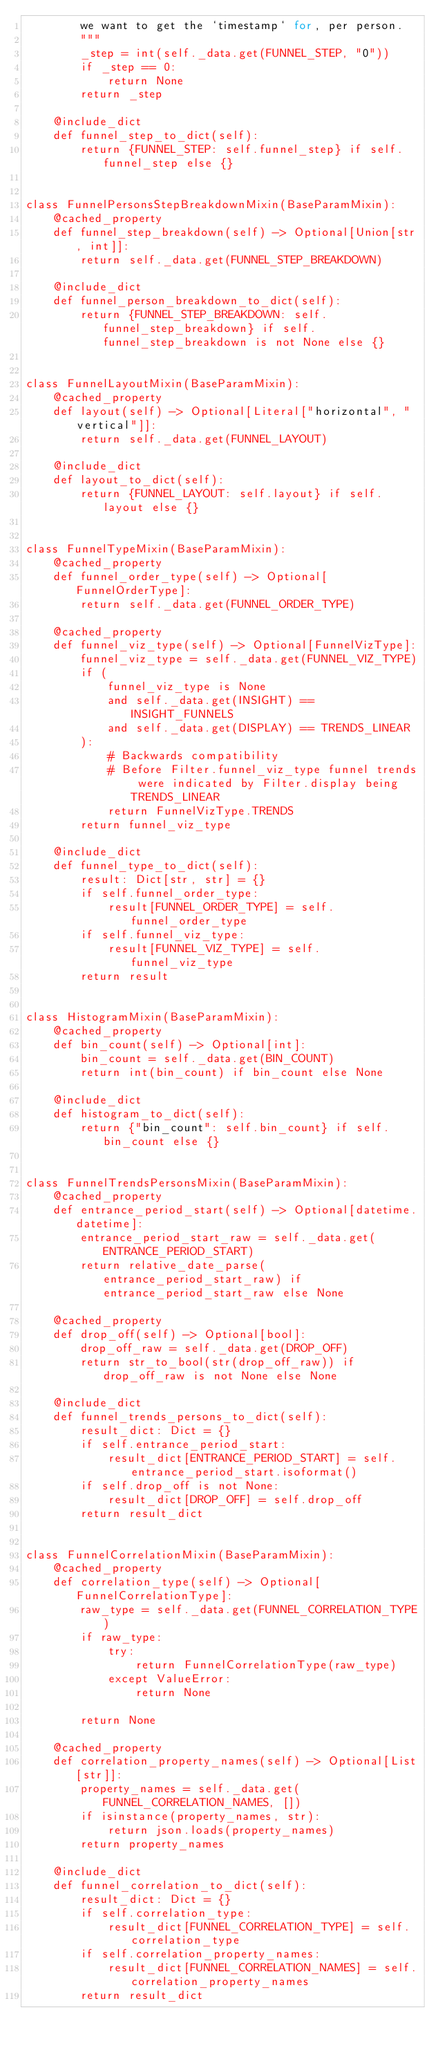<code> <loc_0><loc_0><loc_500><loc_500><_Python_>        we want to get the `timestamp` for, per person.
        """
        _step = int(self._data.get(FUNNEL_STEP, "0"))
        if _step == 0:
            return None
        return _step

    @include_dict
    def funnel_step_to_dict(self):
        return {FUNNEL_STEP: self.funnel_step} if self.funnel_step else {}


class FunnelPersonsStepBreakdownMixin(BaseParamMixin):
    @cached_property
    def funnel_step_breakdown(self) -> Optional[Union[str, int]]:
        return self._data.get(FUNNEL_STEP_BREAKDOWN)

    @include_dict
    def funnel_person_breakdown_to_dict(self):
        return {FUNNEL_STEP_BREAKDOWN: self.funnel_step_breakdown} if self.funnel_step_breakdown is not None else {}


class FunnelLayoutMixin(BaseParamMixin):
    @cached_property
    def layout(self) -> Optional[Literal["horizontal", "vertical"]]:
        return self._data.get(FUNNEL_LAYOUT)

    @include_dict
    def layout_to_dict(self):
        return {FUNNEL_LAYOUT: self.layout} if self.layout else {}


class FunnelTypeMixin(BaseParamMixin):
    @cached_property
    def funnel_order_type(self) -> Optional[FunnelOrderType]:
        return self._data.get(FUNNEL_ORDER_TYPE)

    @cached_property
    def funnel_viz_type(self) -> Optional[FunnelVizType]:
        funnel_viz_type = self._data.get(FUNNEL_VIZ_TYPE)
        if (
            funnel_viz_type is None
            and self._data.get(INSIGHT) == INSIGHT_FUNNELS
            and self._data.get(DISPLAY) == TRENDS_LINEAR
        ):
            # Backwards compatibility
            # Before Filter.funnel_viz_type funnel trends were indicated by Filter.display being TRENDS_LINEAR
            return FunnelVizType.TRENDS
        return funnel_viz_type

    @include_dict
    def funnel_type_to_dict(self):
        result: Dict[str, str] = {}
        if self.funnel_order_type:
            result[FUNNEL_ORDER_TYPE] = self.funnel_order_type
        if self.funnel_viz_type:
            result[FUNNEL_VIZ_TYPE] = self.funnel_viz_type
        return result


class HistogramMixin(BaseParamMixin):
    @cached_property
    def bin_count(self) -> Optional[int]:
        bin_count = self._data.get(BIN_COUNT)
        return int(bin_count) if bin_count else None

    @include_dict
    def histogram_to_dict(self):
        return {"bin_count": self.bin_count} if self.bin_count else {}


class FunnelTrendsPersonsMixin(BaseParamMixin):
    @cached_property
    def entrance_period_start(self) -> Optional[datetime.datetime]:
        entrance_period_start_raw = self._data.get(ENTRANCE_PERIOD_START)
        return relative_date_parse(entrance_period_start_raw) if entrance_period_start_raw else None

    @cached_property
    def drop_off(self) -> Optional[bool]:
        drop_off_raw = self._data.get(DROP_OFF)
        return str_to_bool(str(drop_off_raw)) if drop_off_raw is not None else None

    @include_dict
    def funnel_trends_persons_to_dict(self):
        result_dict: Dict = {}
        if self.entrance_period_start:
            result_dict[ENTRANCE_PERIOD_START] = self.entrance_period_start.isoformat()
        if self.drop_off is not None:
            result_dict[DROP_OFF] = self.drop_off
        return result_dict


class FunnelCorrelationMixin(BaseParamMixin):
    @cached_property
    def correlation_type(self) -> Optional[FunnelCorrelationType]:
        raw_type = self._data.get(FUNNEL_CORRELATION_TYPE)
        if raw_type:
            try:
                return FunnelCorrelationType(raw_type)
            except ValueError:
                return None

        return None

    @cached_property
    def correlation_property_names(self) -> Optional[List[str]]:
        property_names = self._data.get(FUNNEL_CORRELATION_NAMES, [])
        if isinstance(property_names, str):
            return json.loads(property_names)
        return property_names

    @include_dict
    def funnel_correlation_to_dict(self):
        result_dict: Dict = {}
        if self.correlation_type:
            result_dict[FUNNEL_CORRELATION_TYPE] = self.correlation_type
        if self.correlation_property_names:
            result_dict[FUNNEL_CORRELATION_NAMES] = self.correlation_property_names
        return result_dict
</code> 